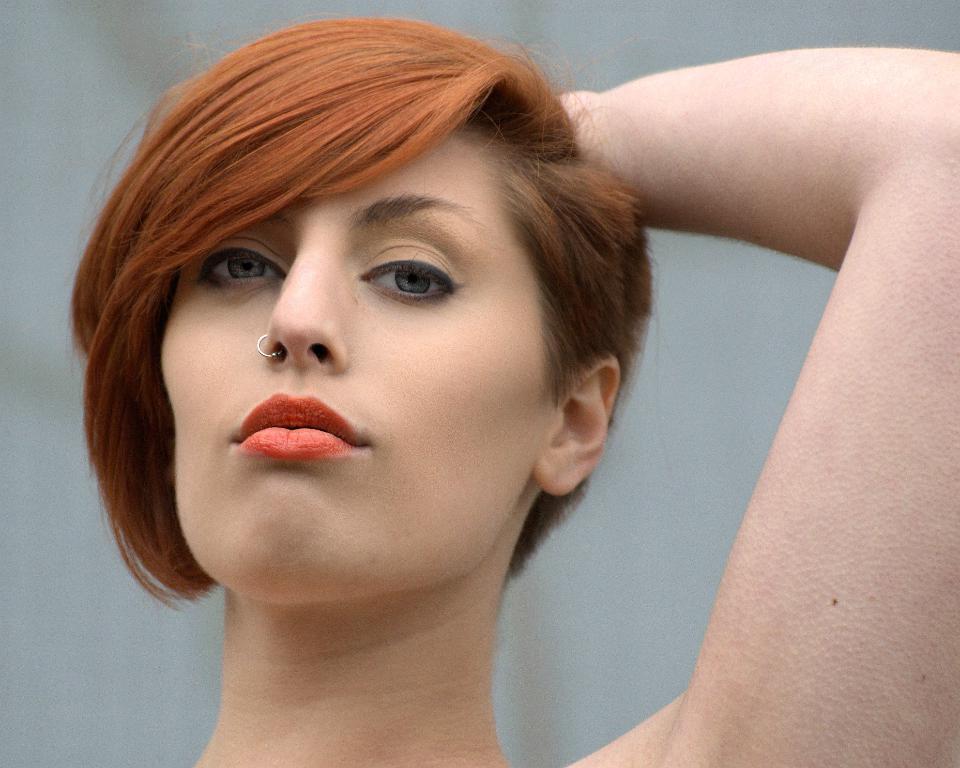In one or two sentences, can you explain what this image depicts? In this image we can see a woman. 